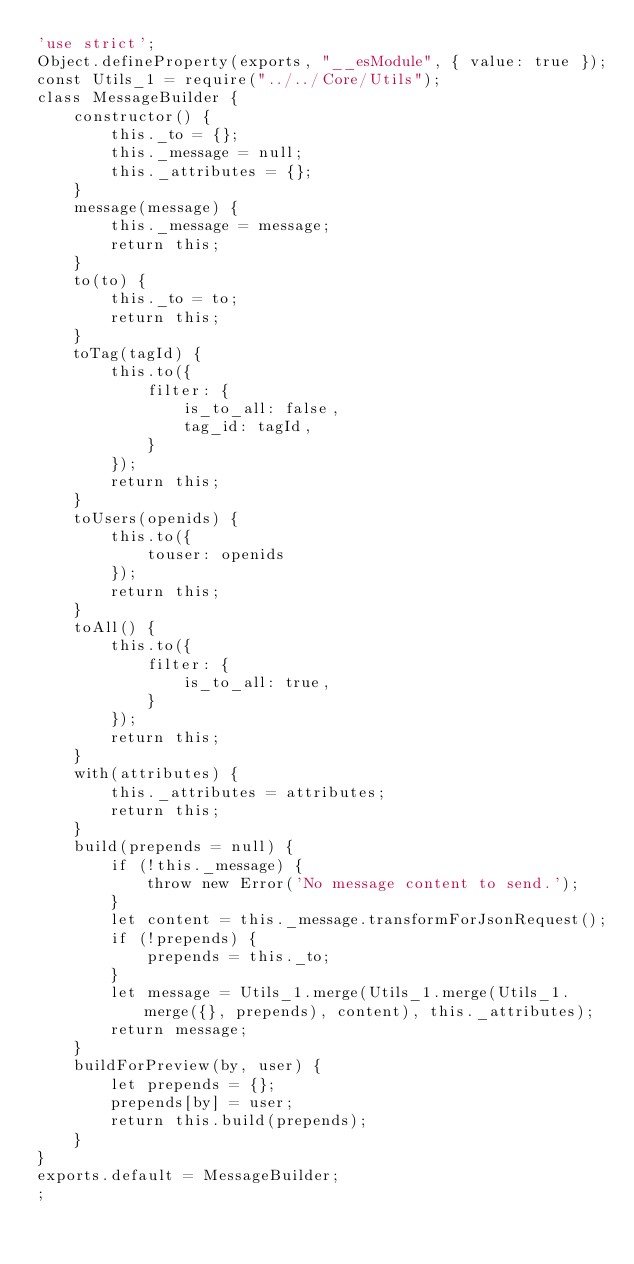<code> <loc_0><loc_0><loc_500><loc_500><_JavaScript_>'use strict';
Object.defineProperty(exports, "__esModule", { value: true });
const Utils_1 = require("../../Core/Utils");
class MessageBuilder {
    constructor() {
        this._to = {};
        this._message = null;
        this._attributes = {};
    }
    message(message) {
        this._message = message;
        return this;
    }
    to(to) {
        this._to = to;
        return this;
    }
    toTag(tagId) {
        this.to({
            filter: {
                is_to_all: false,
                tag_id: tagId,
            }
        });
        return this;
    }
    toUsers(openids) {
        this.to({
            touser: openids
        });
        return this;
    }
    toAll() {
        this.to({
            filter: {
                is_to_all: true,
            }
        });
        return this;
    }
    with(attributes) {
        this._attributes = attributes;
        return this;
    }
    build(prepends = null) {
        if (!this._message) {
            throw new Error('No message content to send.');
        }
        let content = this._message.transformForJsonRequest();
        if (!prepends) {
            prepends = this._to;
        }
        let message = Utils_1.merge(Utils_1.merge(Utils_1.merge({}, prepends), content), this._attributes);
        return message;
    }
    buildForPreview(by, user) {
        let prepends = {};
        prepends[by] = user;
        return this.build(prepends);
    }
}
exports.default = MessageBuilder;
;
</code> 